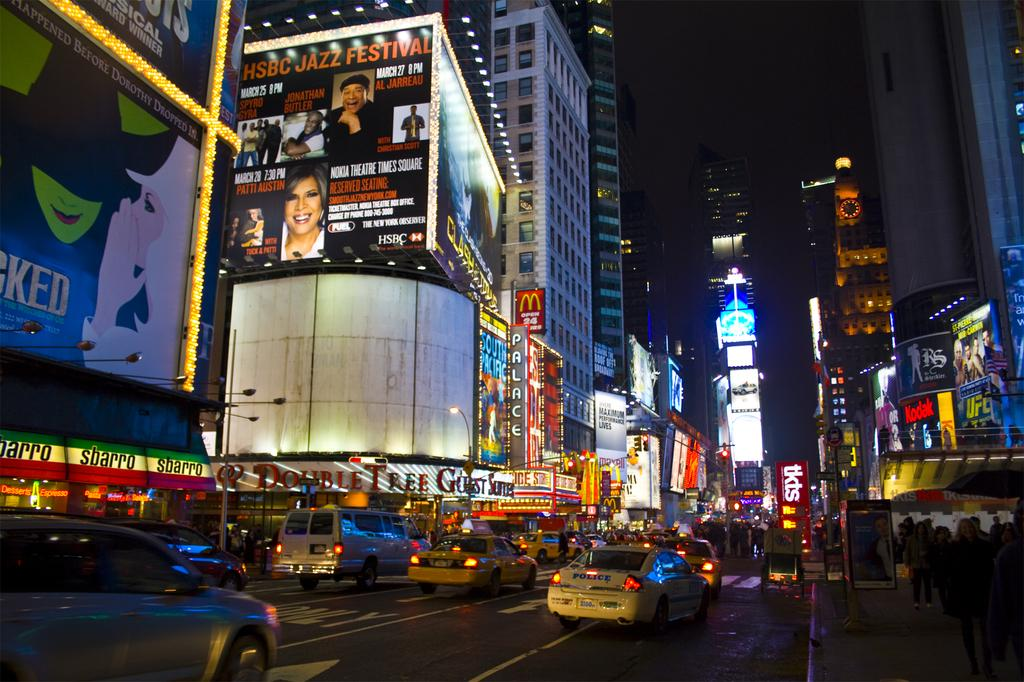What type of structures can be seen in the image? There are buildings in the image. What else can be seen on the buildings in the image? There are hoardings on the buildings in the image. What else is present in the image besides buildings and hoardings? There are vehicles and people in the image. What can be seen illuminating the scene in the image? There are lights in the image. How would you describe the appearance of the sky in the image? The sky appears dark in the image. What type of button can be seen on the brick wall in the image? There is no button present in the image, and the image does not show any brick walls. What is the position of the sun in the image? The sky appears dark in the image, so it is difficult to determine the position of the sun. 